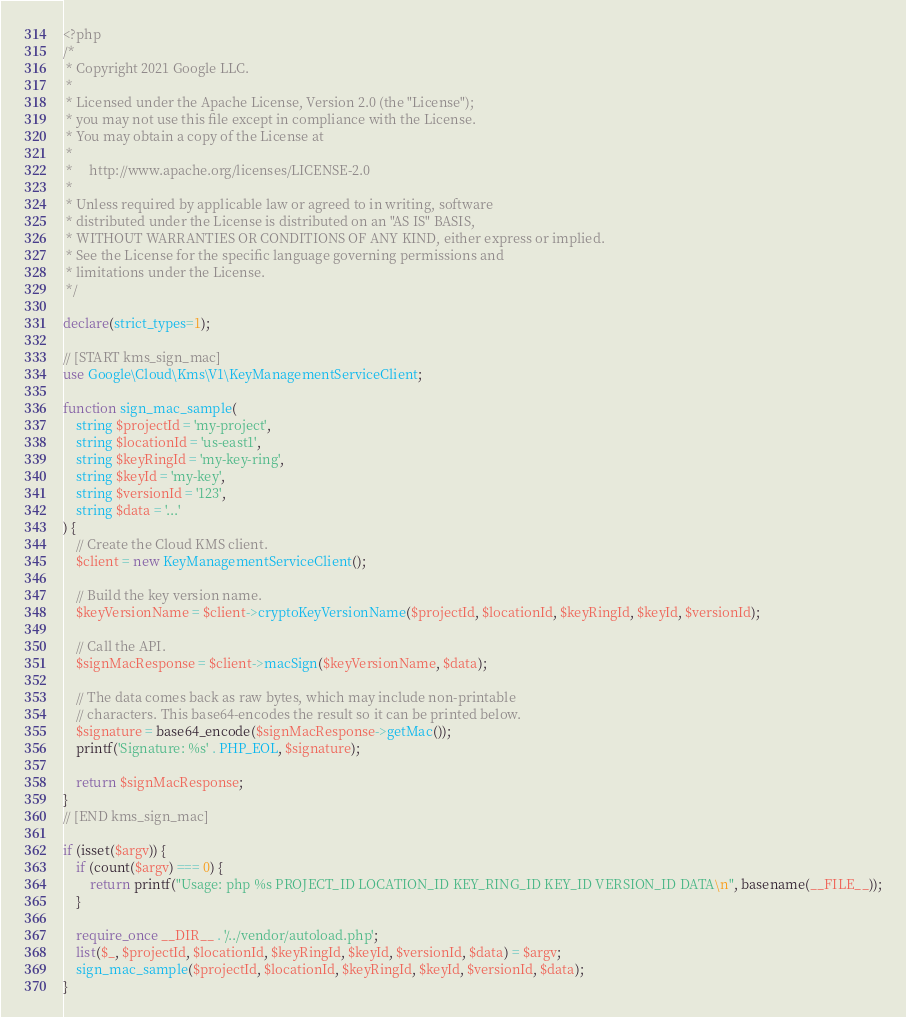<code> <loc_0><loc_0><loc_500><loc_500><_PHP_><?php
/*
 * Copyright 2021 Google LLC.
 *
 * Licensed under the Apache License, Version 2.0 (the "License");
 * you may not use this file except in compliance with the License.
 * You may obtain a copy of the License at
 *
 *     http://www.apache.org/licenses/LICENSE-2.0
 *
 * Unless required by applicable law or agreed to in writing, software
 * distributed under the License is distributed on an "AS IS" BASIS,
 * WITHOUT WARRANTIES OR CONDITIONS OF ANY KIND, either express or implied.
 * See the License for the specific language governing permissions and
 * limitations under the License.
 */

declare(strict_types=1);

// [START kms_sign_mac]
use Google\Cloud\Kms\V1\KeyManagementServiceClient;

function sign_mac_sample(
    string $projectId = 'my-project',
    string $locationId = 'us-east1',
    string $keyRingId = 'my-key-ring',
    string $keyId = 'my-key',
    string $versionId = '123',
    string $data = '...'
) {
    // Create the Cloud KMS client.
    $client = new KeyManagementServiceClient();

    // Build the key version name.
    $keyVersionName = $client->cryptoKeyVersionName($projectId, $locationId, $keyRingId, $keyId, $versionId);

    // Call the API.
    $signMacResponse = $client->macSign($keyVersionName, $data);

    // The data comes back as raw bytes, which may include non-printable
    // characters. This base64-encodes the result so it can be printed below.
    $signature = base64_encode($signMacResponse->getMac());
    printf('Signature: %s' . PHP_EOL, $signature);

    return $signMacResponse;
}
// [END kms_sign_mac]

if (isset($argv)) {
    if (count($argv) === 0) {
        return printf("Usage: php %s PROJECT_ID LOCATION_ID KEY_RING_ID KEY_ID VERSION_ID DATA\n", basename(__FILE__));
    }

    require_once __DIR__ . '/../vendor/autoload.php';
    list($_, $projectId, $locationId, $keyRingId, $keyId, $versionId, $data) = $argv;
    sign_mac_sample($projectId, $locationId, $keyRingId, $keyId, $versionId, $data);
}
</code> 